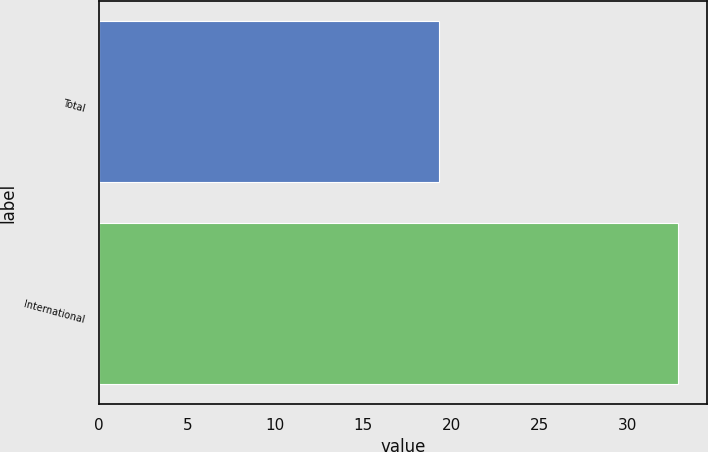<chart> <loc_0><loc_0><loc_500><loc_500><bar_chart><fcel>Total<fcel>International<nl><fcel>19.3<fcel>32.9<nl></chart> 